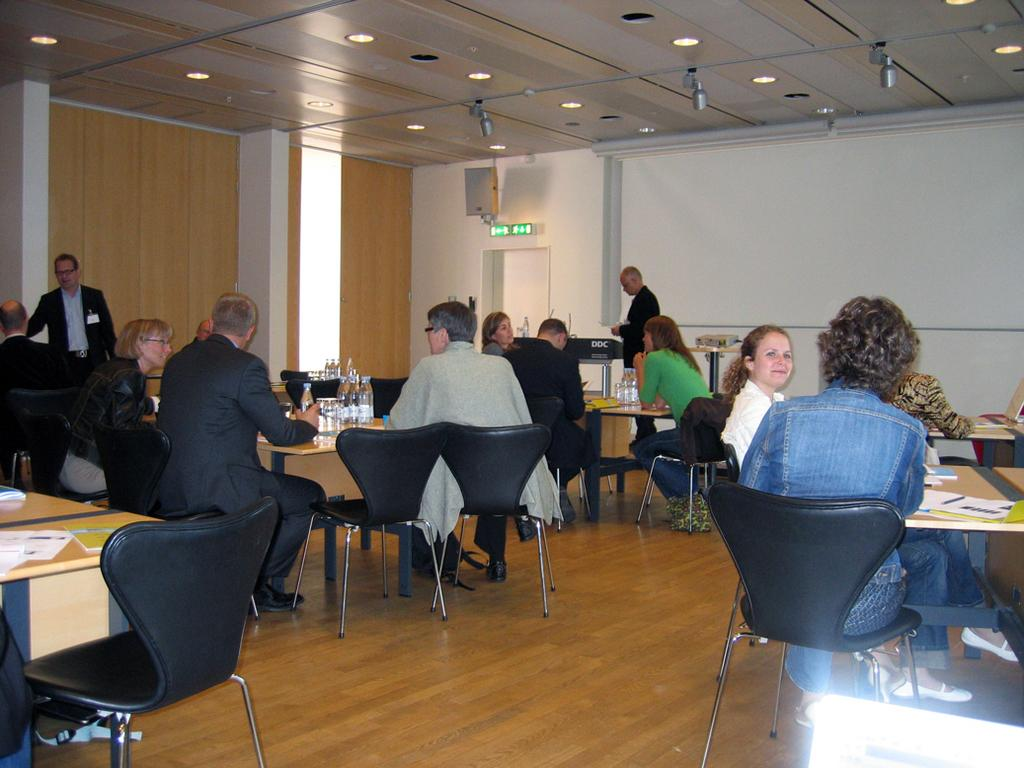How many people are in the image? There is a group of people in the image, but the exact number is not specified. What are the people doing in the image? The people are sitting in the image. What is located in front of the people? There is a table in front of the people. What items can be seen on the table? There are papers and water bottles on the table. What is the opinion of the people about the flight in the image? There is no mention of a flight or any opinions about it in the image. 